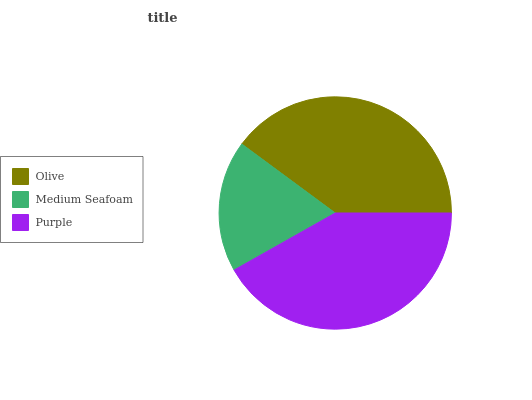Is Medium Seafoam the minimum?
Answer yes or no. Yes. Is Purple the maximum?
Answer yes or no. Yes. Is Purple the minimum?
Answer yes or no. No. Is Medium Seafoam the maximum?
Answer yes or no. No. Is Purple greater than Medium Seafoam?
Answer yes or no. Yes. Is Medium Seafoam less than Purple?
Answer yes or no. Yes. Is Medium Seafoam greater than Purple?
Answer yes or no. No. Is Purple less than Medium Seafoam?
Answer yes or no. No. Is Olive the high median?
Answer yes or no. Yes. Is Olive the low median?
Answer yes or no. Yes. Is Purple the high median?
Answer yes or no. No. Is Purple the low median?
Answer yes or no. No. 